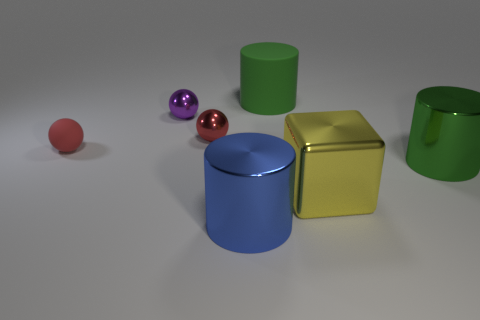Add 1 green things. How many objects exist? 8 Subtract all blocks. How many objects are left? 6 Add 7 small red things. How many small red things are left? 9 Add 5 metallic blocks. How many metallic blocks exist? 6 Subtract 0 yellow spheres. How many objects are left? 7 Subtract all brown metal cubes. Subtract all large green metal cylinders. How many objects are left? 6 